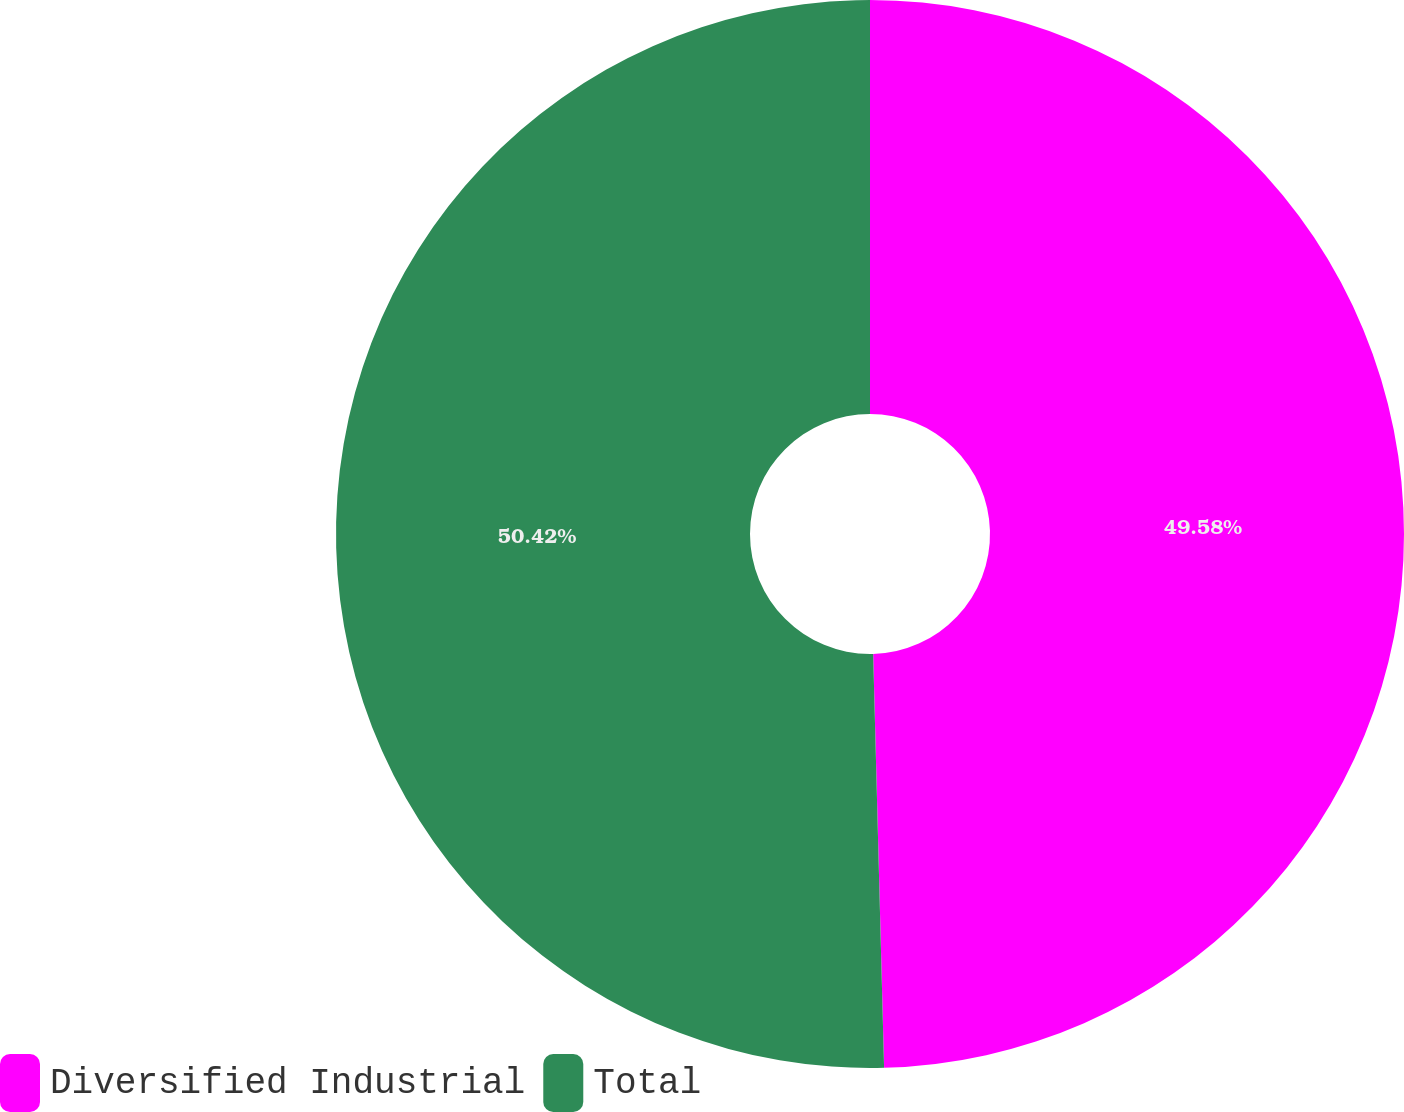Convert chart. <chart><loc_0><loc_0><loc_500><loc_500><pie_chart><fcel>Diversified Industrial<fcel>Total<nl><fcel>49.58%<fcel>50.42%<nl></chart> 